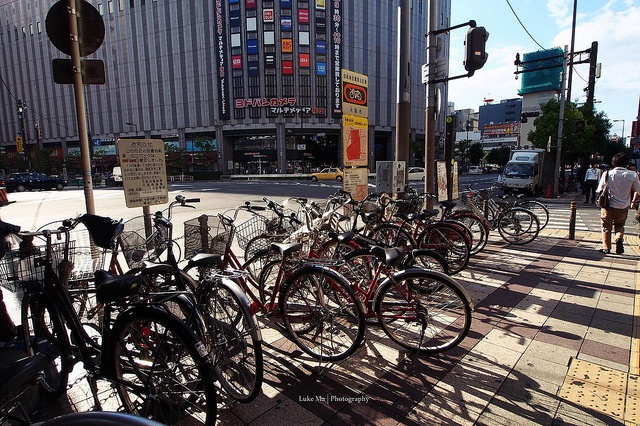Describe the objects in this image and their specific colors. I can see bicycle in gray, black, white, and darkgray tones, bicycle in gray, black, ivory, and darkgray tones, bicycle in gray, black, maroon, and darkgray tones, bicycle in gray, black, lightgray, and darkgray tones, and bicycle in gray, black, white, and darkgray tones in this image. 